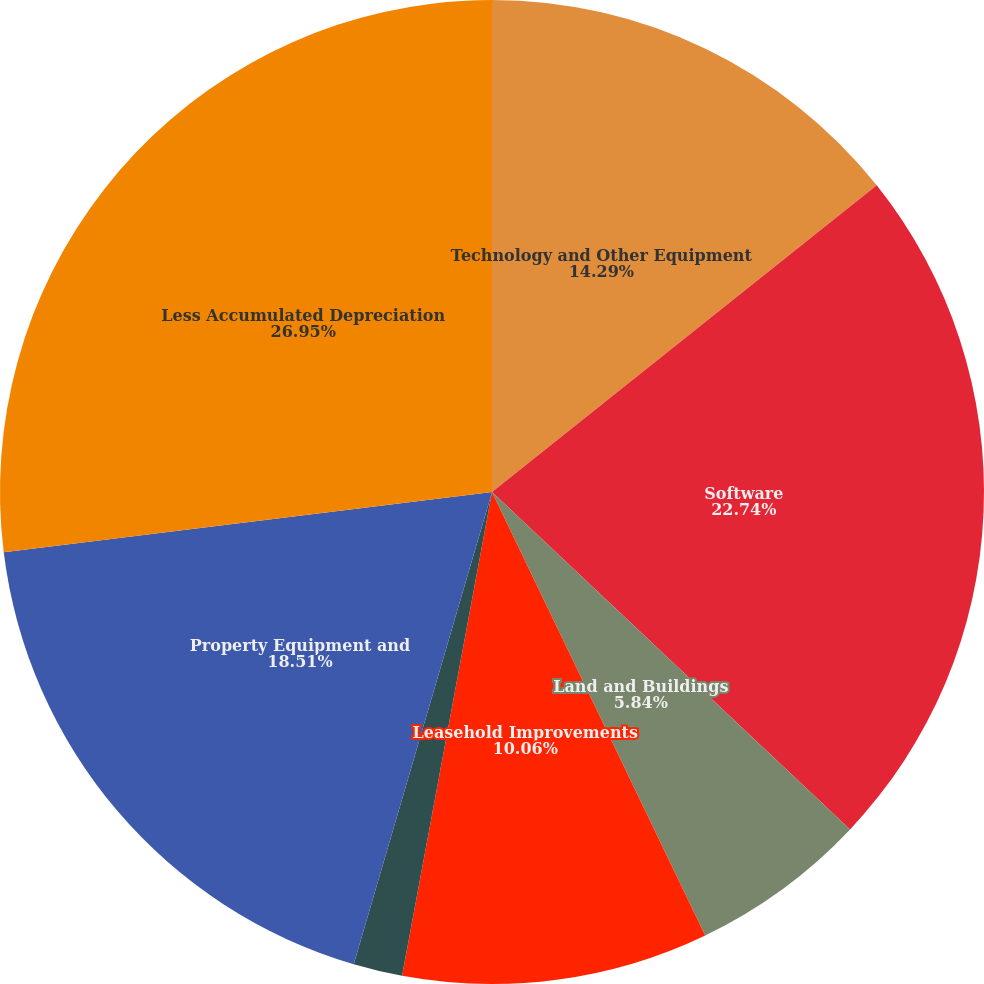Convert chart to OTSL. <chart><loc_0><loc_0><loc_500><loc_500><pie_chart><fcel>Technology and Other Equipment<fcel>Software<fcel>Land and Buildings<fcel>Leasehold Improvements<fcel>Work in Process<fcel>Property Equipment and<fcel>Less Accumulated Depreciation<nl><fcel>14.29%<fcel>22.74%<fcel>5.84%<fcel>10.06%<fcel>1.61%<fcel>18.51%<fcel>26.96%<nl></chart> 